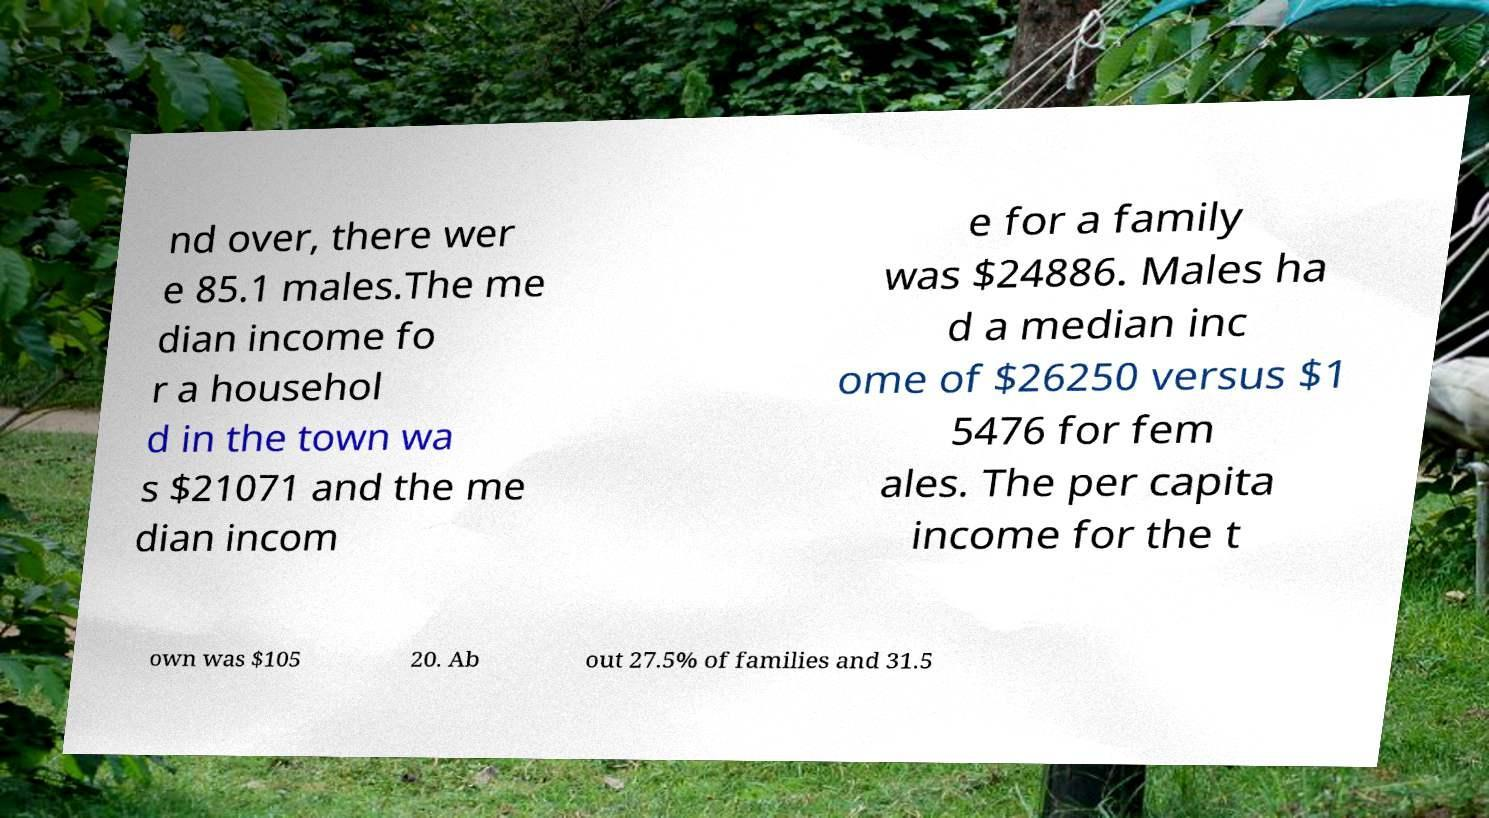What messages or text are displayed in this image? I need them in a readable, typed format. nd over, there wer e 85.1 males.The me dian income fo r a househol d in the town wa s $21071 and the me dian incom e for a family was $24886. Males ha d a median inc ome of $26250 versus $1 5476 for fem ales. The per capita income for the t own was $105 20. Ab out 27.5% of families and 31.5 